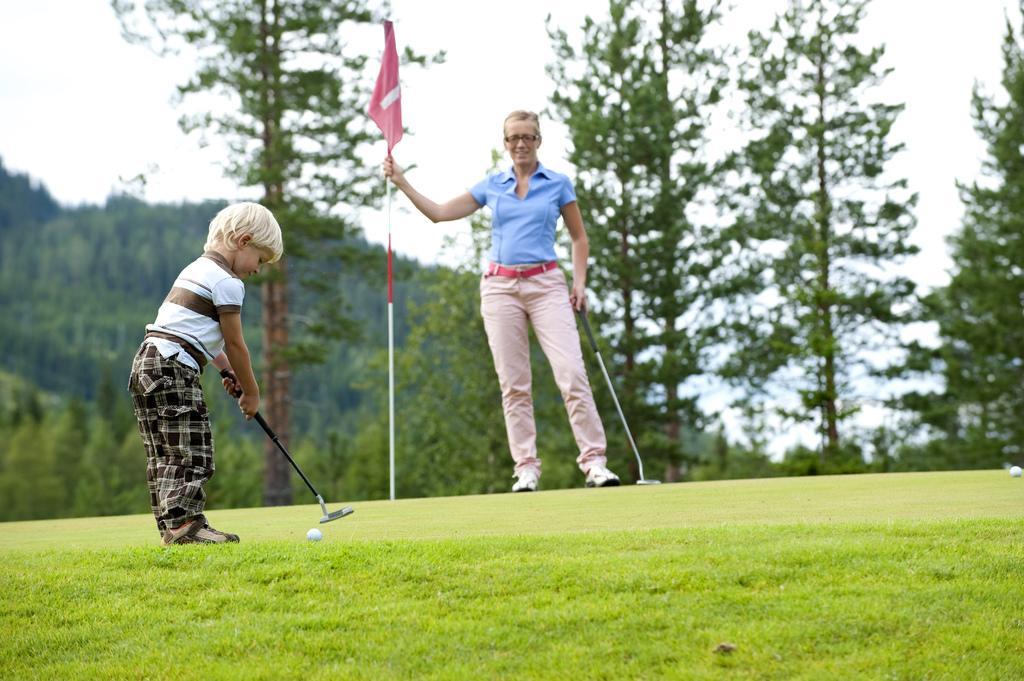Could you give a brief overview of what you see in this image? In this image I can see two persons. In front the person is wearing brown and black color dress and holding the golf stick and I can also see the ball. In the background I can see the flag, few trees in green color and the sky is in white color. 